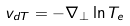<formula> <loc_0><loc_0><loc_500><loc_500>v _ { d T } = - \nabla _ { \perp } \ln T _ { e }</formula> 